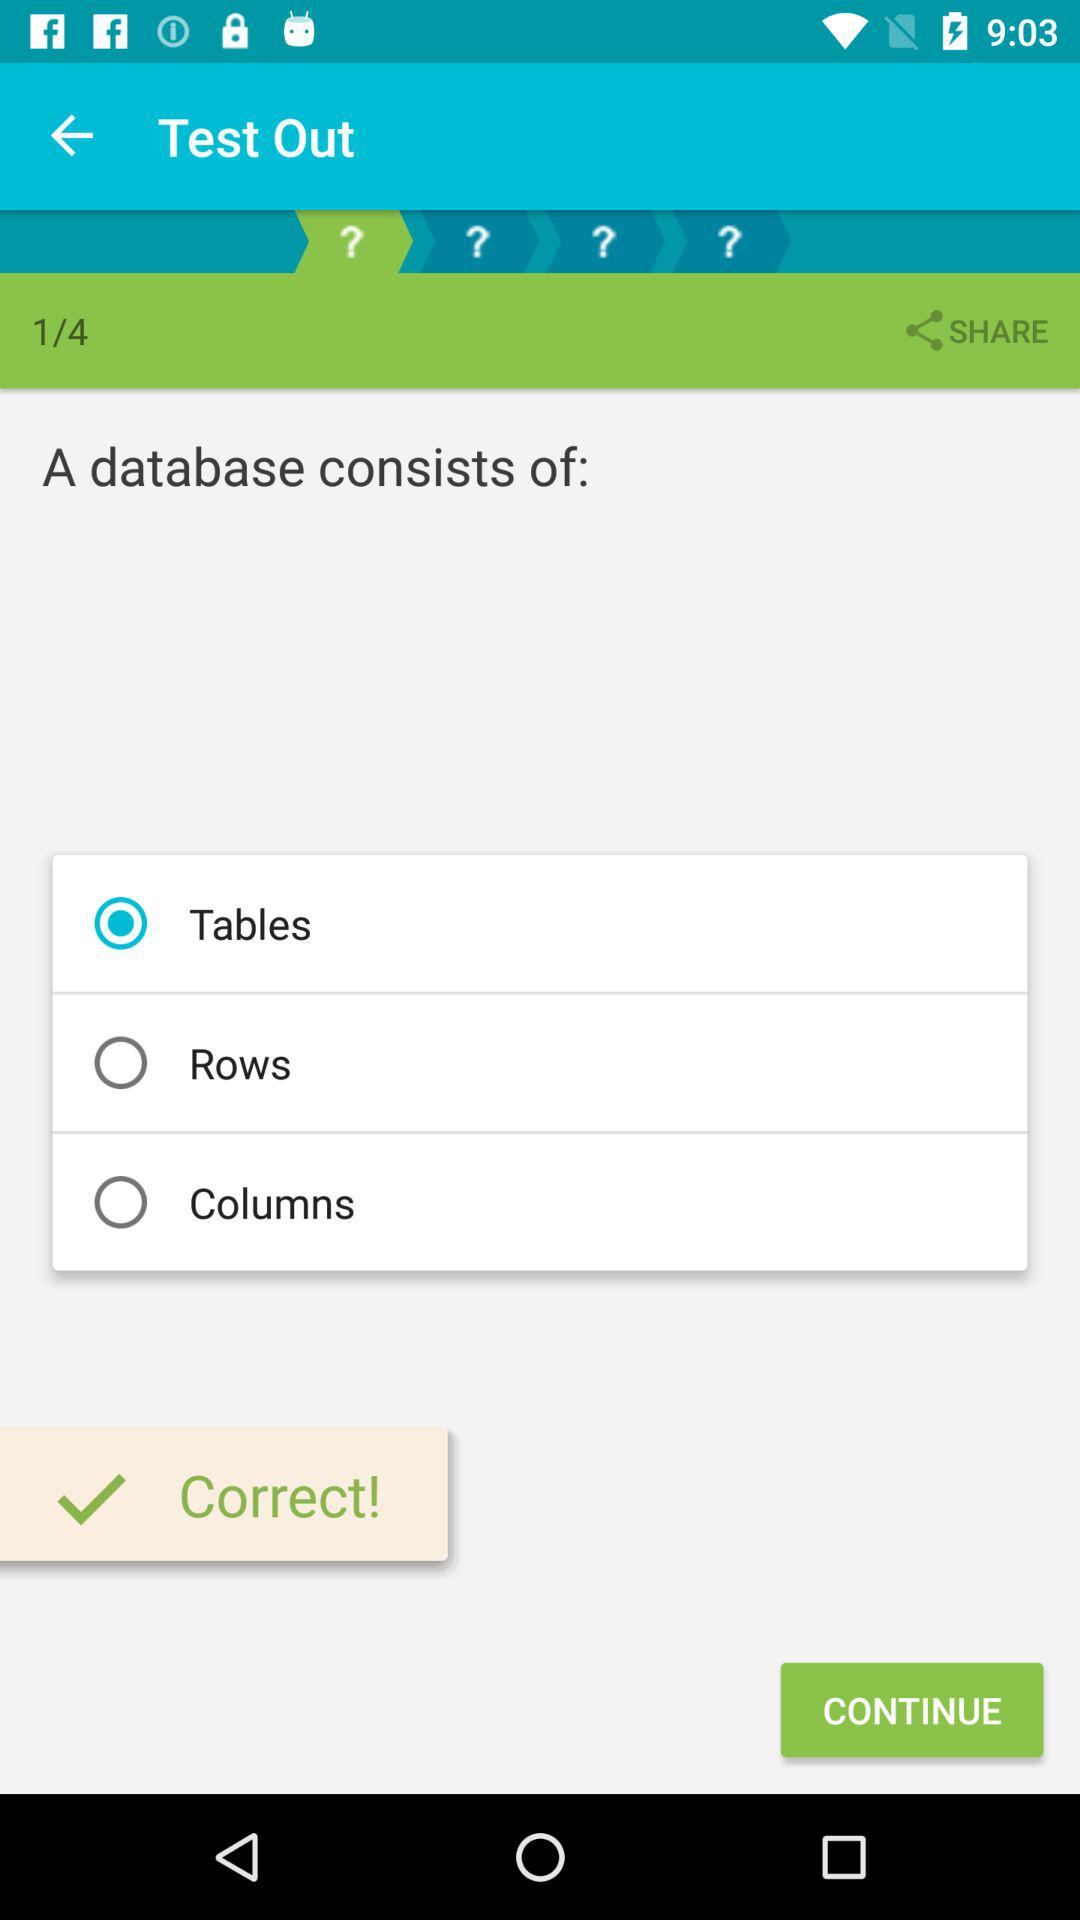How many questions are there in total?
Answer the question using a single word or phrase. 4 